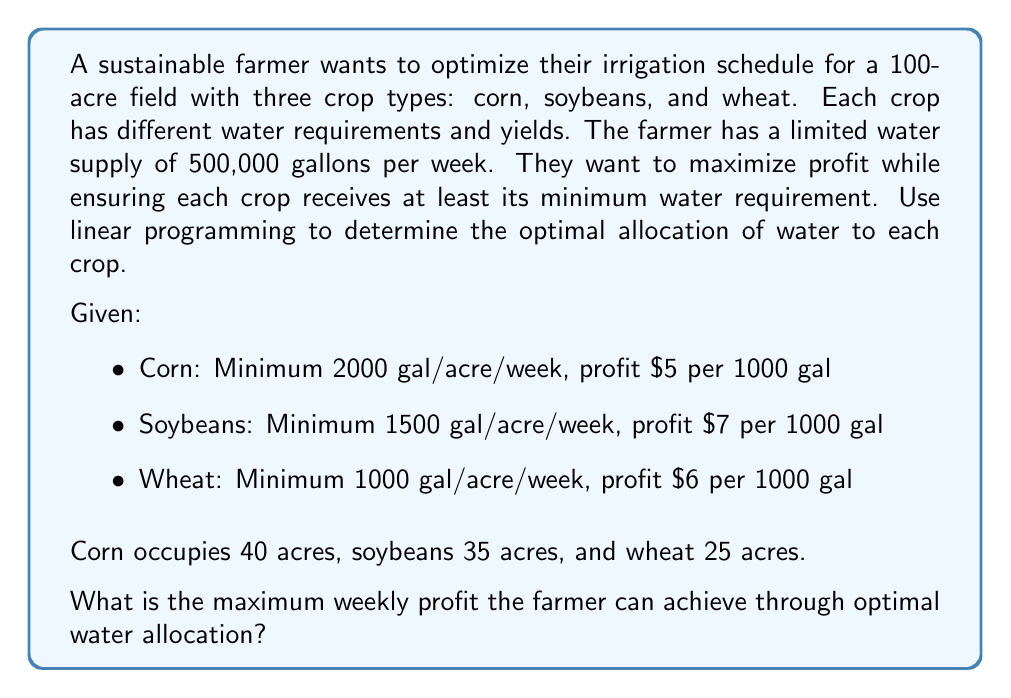What is the answer to this math problem? To solve this linear programming problem, we need to:
1. Define variables
2. Set up the objective function
3. Establish constraints
4. Solve the linear program

Step 1: Define variables
Let $x_1$, $x_2$, and $x_3$ be the amount of water (in thousands of gallons) allocated to corn, soybeans, and wheat respectively.

Step 2: Objective function
We want to maximize profit:
$$\text{Maximize } Z = 5x_1 + 7x_2 + 6x_3$$

Step 3: Constraints
Water supply constraint:
$$x_1 + x_2 + x_3 \leq 500$$

Minimum water requirements:
$$x_1 \geq 40 \cdot 2 = 80 \text{ (Corn)}$$
$$x_2 \geq 35 \cdot 1.5 = 52.5 \text{ (Soybeans)}$$
$$x_3 \geq 25 \cdot 1 = 25 \text{ (Wheat)}$$

Non-negativity constraints:
$$x_1, x_2, x_3 \geq 0$$

Step 4: Solve the linear program
We can solve this using the simplex method or a linear programming solver. The optimal solution is:

$$x_1 = 80, x_2 = 395, x_3 = 25$$

This means:
- Allocate 80,000 gallons to corn (minimum requirement)
- Allocate 395,000 gallons to soybeans
- Allocate 25,000 gallons to wheat (minimum requirement)

The maximum profit can be calculated by substituting these values into the objective function:

$$Z = 5(80) + 7(395) + 6(25) = 400 + 2765 + 150 = 3315$$

Therefore, the maximum weekly profit is $3,315.
Answer: $3,315 